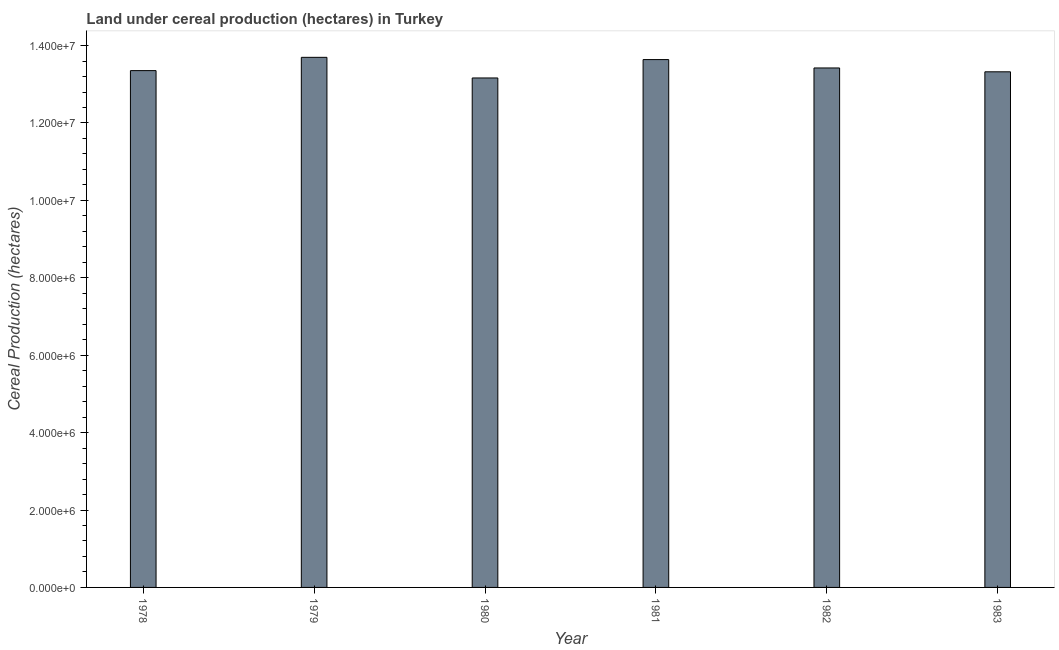Does the graph contain grids?
Keep it short and to the point. No. What is the title of the graph?
Make the answer very short. Land under cereal production (hectares) in Turkey. What is the label or title of the Y-axis?
Keep it short and to the point. Cereal Production (hectares). What is the land under cereal production in 1981?
Provide a short and direct response. 1.36e+07. Across all years, what is the maximum land under cereal production?
Offer a terse response. 1.37e+07. Across all years, what is the minimum land under cereal production?
Your answer should be very brief. 1.32e+07. In which year was the land under cereal production maximum?
Keep it short and to the point. 1979. What is the sum of the land under cereal production?
Offer a terse response. 8.06e+07. What is the difference between the land under cereal production in 1981 and 1982?
Offer a terse response. 2.16e+05. What is the average land under cereal production per year?
Your response must be concise. 1.34e+07. What is the median land under cereal production?
Your answer should be very brief. 1.34e+07. Is the land under cereal production in 1981 less than that in 1982?
Your response must be concise. No. What is the difference between the highest and the second highest land under cereal production?
Your answer should be compact. 5.82e+04. Is the sum of the land under cereal production in 1978 and 1982 greater than the maximum land under cereal production across all years?
Your answer should be compact. Yes. What is the difference between the highest and the lowest land under cereal production?
Your response must be concise. 5.33e+05. In how many years, is the land under cereal production greater than the average land under cereal production taken over all years?
Make the answer very short. 2. How many bars are there?
Ensure brevity in your answer.  6. How many years are there in the graph?
Your answer should be very brief. 6. What is the Cereal Production (hectares) in 1978?
Give a very brief answer. 1.34e+07. What is the Cereal Production (hectares) of 1979?
Provide a succinct answer. 1.37e+07. What is the Cereal Production (hectares) in 1980?
Make the answer very short. 1.32e+07. What is the Cereal Production (hectares) of 1981?
Your response must be concise. 1.36e+07. What is the Cereal Production (hectares) of 1982?
Ensure brevity in your answer.  1.34e+07. What is the Cereal Production (hectares) in 1983?
Keep it short and to the point. 1.33e+07. What is the difference between the Cereal Production (hectares) in 1978 and 1979?
Ensure brevity in your answer.  -3.43e+05. What is the difference between the Cereal Production (hectares) in 1978 and 1980?
Keep it short and to the point. 1.90e+05. What is the difference between the Cereal Production (hectares) in 1978 and 1981?
Your response must be concise. -2.85e+05. What is the difference between the Cereal Production (hectares) in 1978 and 1982?
Your answer should be compact. -6.89e+04. What is the difference between the Cereal Production (hectares) in 1978 and 1983?
Give a very brief answer. 3.05e+04. What is the difference between the Cereal Production (hectares) in 1979 and 1980?
Your response must be concise. 5.33e+05. What is the difference between the Cereal Production (hectares) in 1979 and 1981?
Keep it short and to the point. 5.82e+04. What is the difference between the Cereal Production (hectares) in 1979 and 1982?
Your answer should be very brief. 2.75e+05. What is the difference between the Cereal Production (hectares) in 1979 and 1983?
Offer a terse response. 3.74e+05. What is the difference between the Cereal Production (hectares) in 1980 and 1981?
Your answer should be very brief. -4.75e+05. What is the difference between the Cereal Production (hectares) in 1980 and 1982?
Offer a very short reply. -2.59e+05. What is the difference between the Cereal Production (hectares) in 1980 and 1983?
Make the answer very short. -1.59e+05. What is the difference between the Cereal Production (hectares) in 1981 and 1982?
Your response must be concise. 2.16e+05. What is the difference between the Cereal Production (hectares) in 1981 and 1983?
Keep it short and to the point. 3.16e+05. What is the difference between the Cereal Production (hectares) in 1982 and 1983?
Your answer should be compact. 9.94e+04. What is the ratio of the Cereal Production (hectares) in 1978 to that in 1979?
Keep it short and to the point. 0.97. What is the ratio of the Cereal Production (hectares) in 1978 to that in 1980?
Provide a short and direct response. 1.01. What is the ratio of the Cereal Production (hectares) in 1979 to that in 1980?
Keep it short and to the point. 1.04. What is the ratio of the Cereal Production (hectares) in 1979 to that in 1981?
Ensure brevity in your answer.  1. What is the ratio of the Cereal Production (hectares) in 1979 to that in 1983?
Your answer should be very brief. 1.03. What is the ratio of the Cereal Production (hectares) in 1980 to that in 1981?
Ensure brevity in your answer.  0.96. What is the ratio of the Cereal Production (hectares) in 1980 to that in 1982?
Offer a terse response. 0.98. What is the ratio of the Cereal Production (hectares) in 1980 to that in 1983?
Make the answer very short. 0.99. What is the ratio of the Cereal Production (hectares) in 1981 to that in 1982?
Keep it short and to the point. 1.02. What is the ratio of the Cereal Production (hectares) in 1981 to that in 1983?
Your response must be concise. 1.02. What is the ratio of the Cereal Production (hectares) in 1982 to that in 1983?
Your answer should be compact. 1.01. 